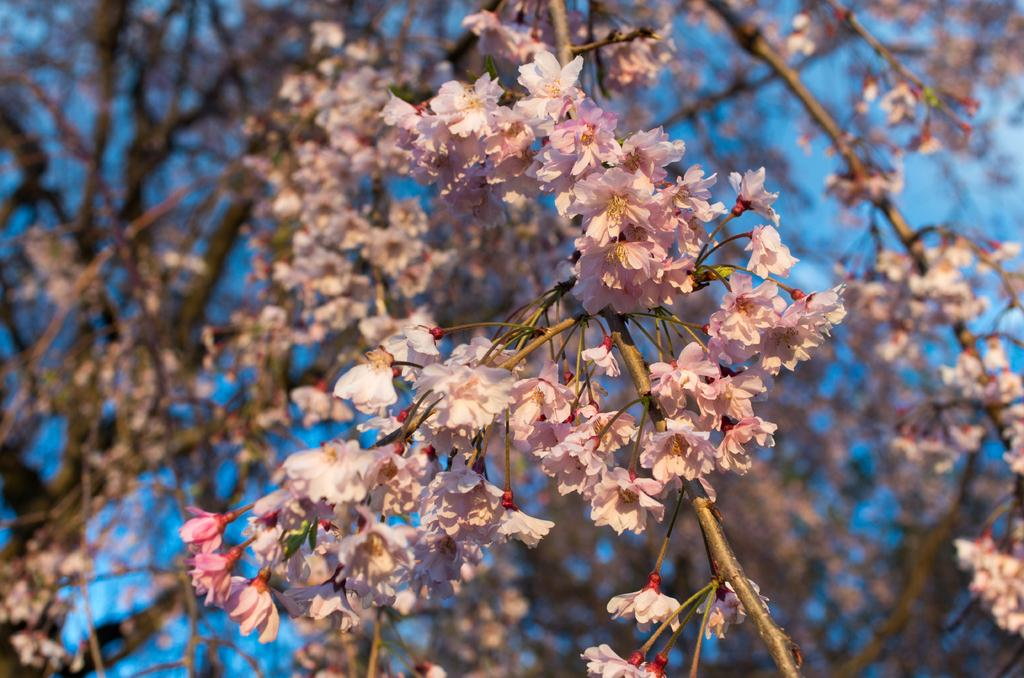What type of flora is present in the image? There are flowers in the image. What colors are the flowers? The flowers are in pink and white colors. What can be seen in the background of the image? The sky is visible in the background of the image. What is the color of the sky in the image? The sky is blue in color. Can you tell me how many owls are sitting on the flowers in the image? There are no owls present in the image; it features flowers in pink and white colors with a blue sky in the background. 